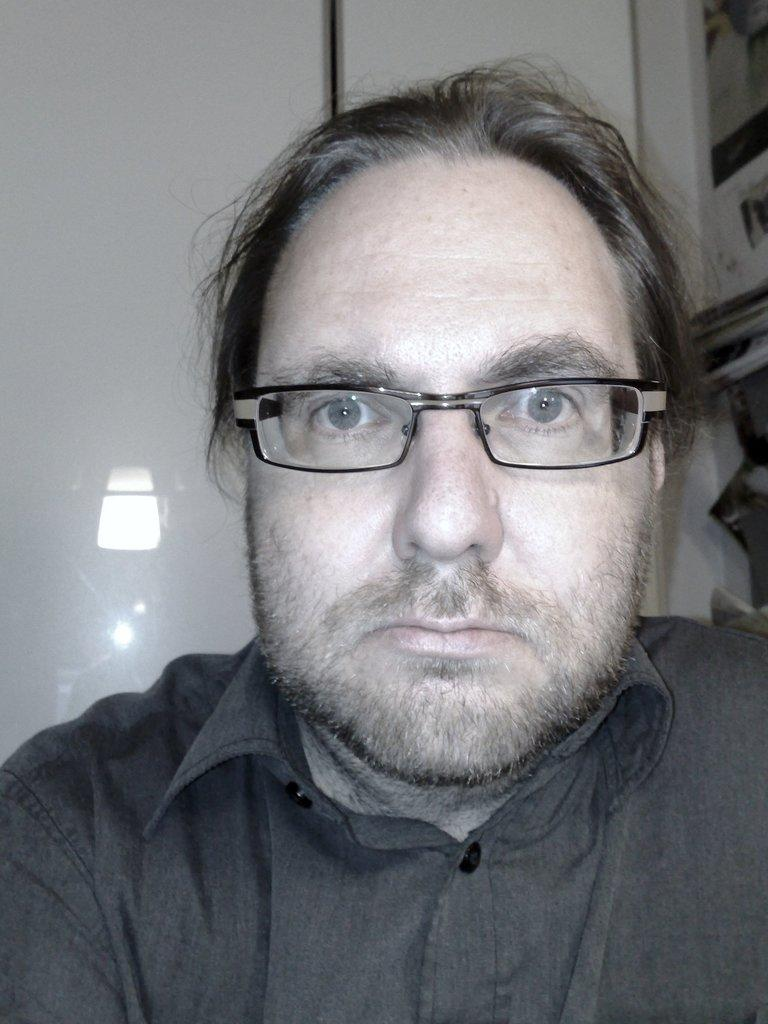Who is present in the image? There is a man in the image. What is the man wearing on his face? The man is wearing spectacles. What type of clothing is the man wearing? The man is wearing a shirt. What can be seen in the background of the image? There is a door in the background of the image. What is present in the right corner of the image? There are objects in the right corner of the image. What type of worm can be seen crawling on the man's shirt in the image? There is no worm present on the man's shirt in the image. What scent is emanating from the objects in the right corner of the image? There is no mention of a scent in the image, and the objects in the right corner are not described in detail. 